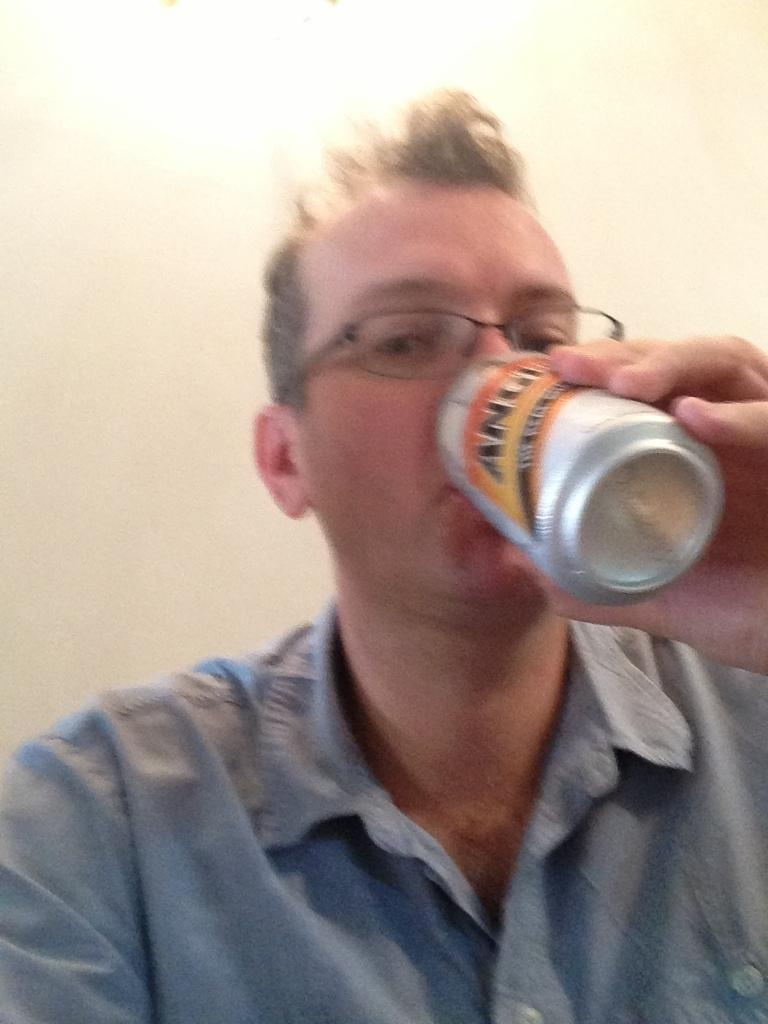Who is present in the image? There is a man in the image. What is the man holding in his hand? The man is holding a drink can in his hand. What is the man doing with the drink can? The man is drinking from the drink can. What can be seen behind the man? There is a wall behind the man. What type of glue is the man using to balance on the wall in the image? There is no glue or wall present in the image, and the man is not balancing. 